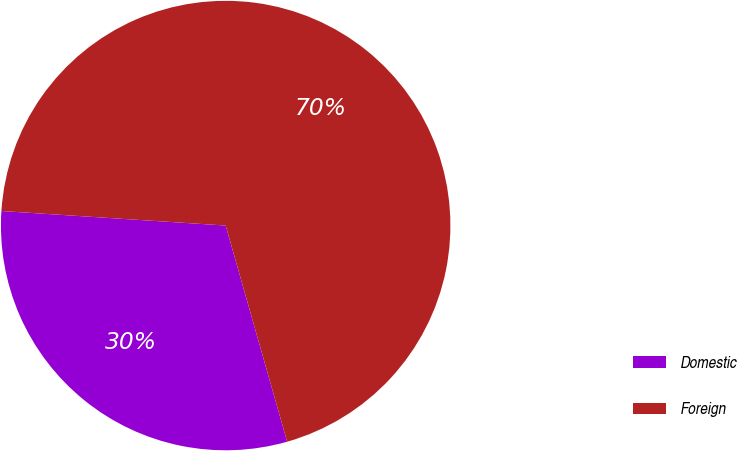Convert chart. <chart><loc_0><loc_0><loc_500><loc_500><pie_chart><fcel>Domestic<fcel>Foreign<nl><fcel>30.44%<fcel>69.56%<nl></chart> 